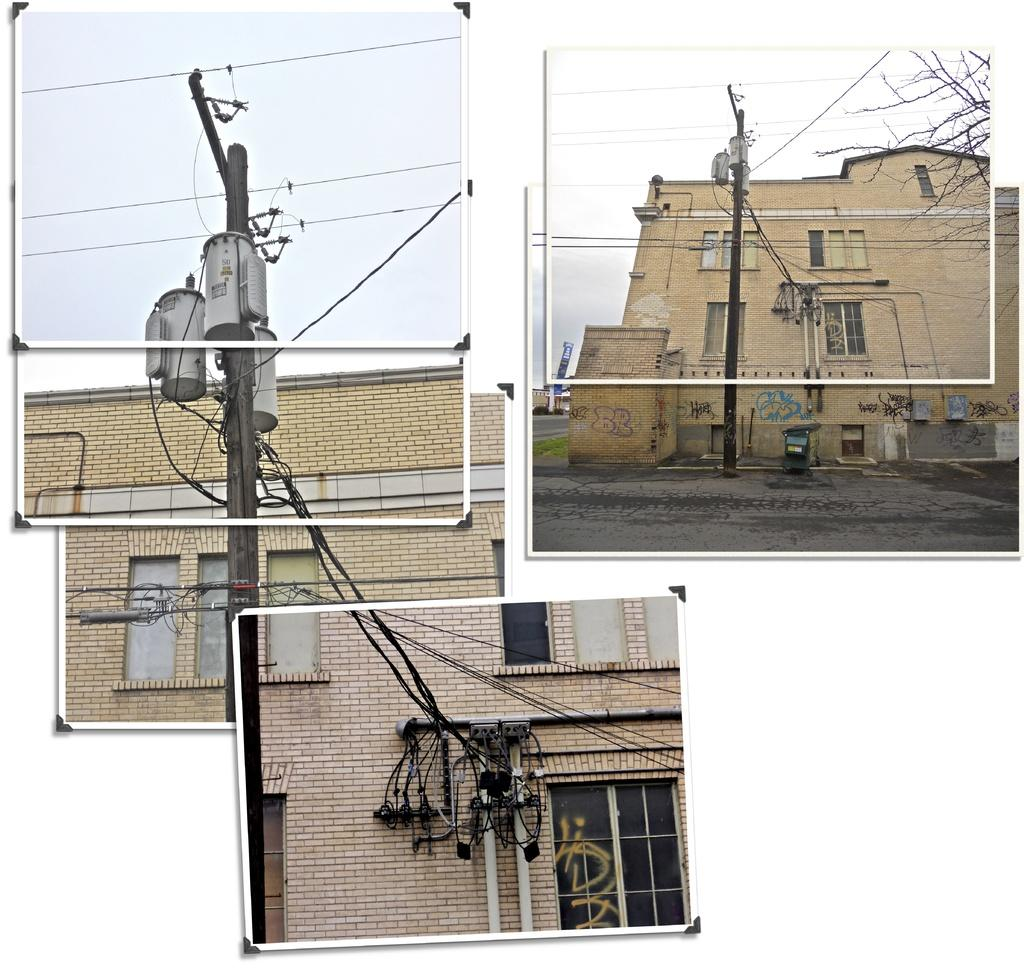What is depicted in the different frames in the image? The frames contain images of buildings, windows, wires, and poles. What can be seen in the background of the images within the frames? The sky is visible in the frames. What type of structures are shown in the images within the frames? The images within the frames contain images of buildings. Can you tell me how many boats are visible in the image? There are no boats present in the image; the frames contain images of buildings, windows, wires, and poles. What scientific discoveries are depicted in the images within the frames? There is no reference to scientific discoveries in the images within the frames; they contain images of buildings, windows, wires, and poles. 